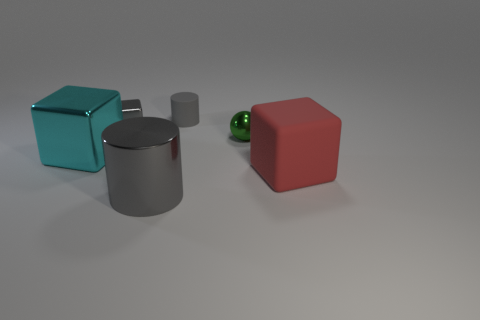Is there a matte block of the same size as the green thing?
Offer a terse response. No. What material is the green thing that is the same size as the gray rubber cylinder?
Ensure brevity in your answer.  Metal. The metal thing on the right side of the small gray rubber cylinder has what shape?
Offer a very short reply. Sphere. Does the big thing that is behind the red object have the same material as the large object that is to the right of the tiny cylinder?
Offer a terse response. No. How many cyan metal objects have the same shape as the red matte thing?
Your answer should be compact. 1. What is the material of the big object that is the same color as the tiny rubber cylinder?
Your response must be concise. Metal. What number of things are big cyan cubes or big objects that are right of the tiny gray cube?
Keep it short and to the point. 3. What is the material of the cyan thing?
Provide a succinct answer. Metal. There is another big object that is the same shape as the large rubber object; what is it made of?
Ensure brevity in your answer.  Metal. What is the color of the rubber object behind the cube in front of the cyan block?
Keep it short and to the point. Gray. 